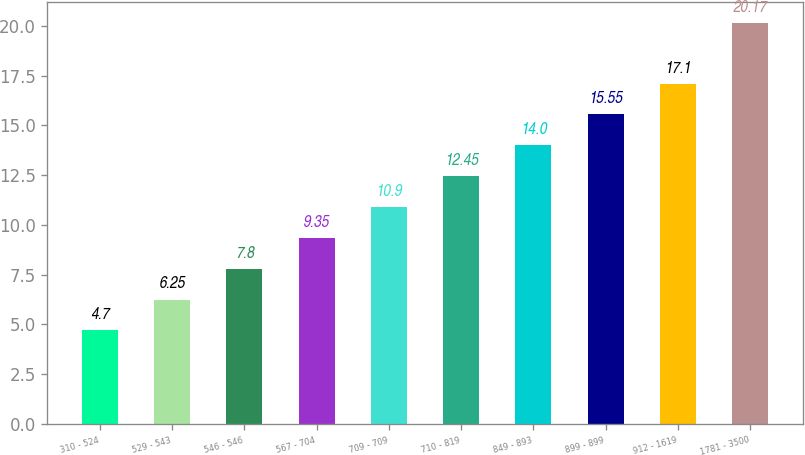Convert chart to OTSL. <chart><loc_0><loc_0><loc_500><loc_500><bar_chart><fcel>310 - 524<fcel>529 - 543<fcel>546 - 546<fcel>567 - 704<fcel>709 - 709<fcel>710 - 819<fcel>849 - 893<fcel>899 - 899<fcel>912 - 1619<fcel>1781 - 3500<nl><fcel>4.7<fcel>6.25<fcel>7.8<fcel>9.35<fcel>10.9<fcel>12.45<fcel>14<fcel>15.55<fcel>17.1<fcel>20.17<nl></chart> 